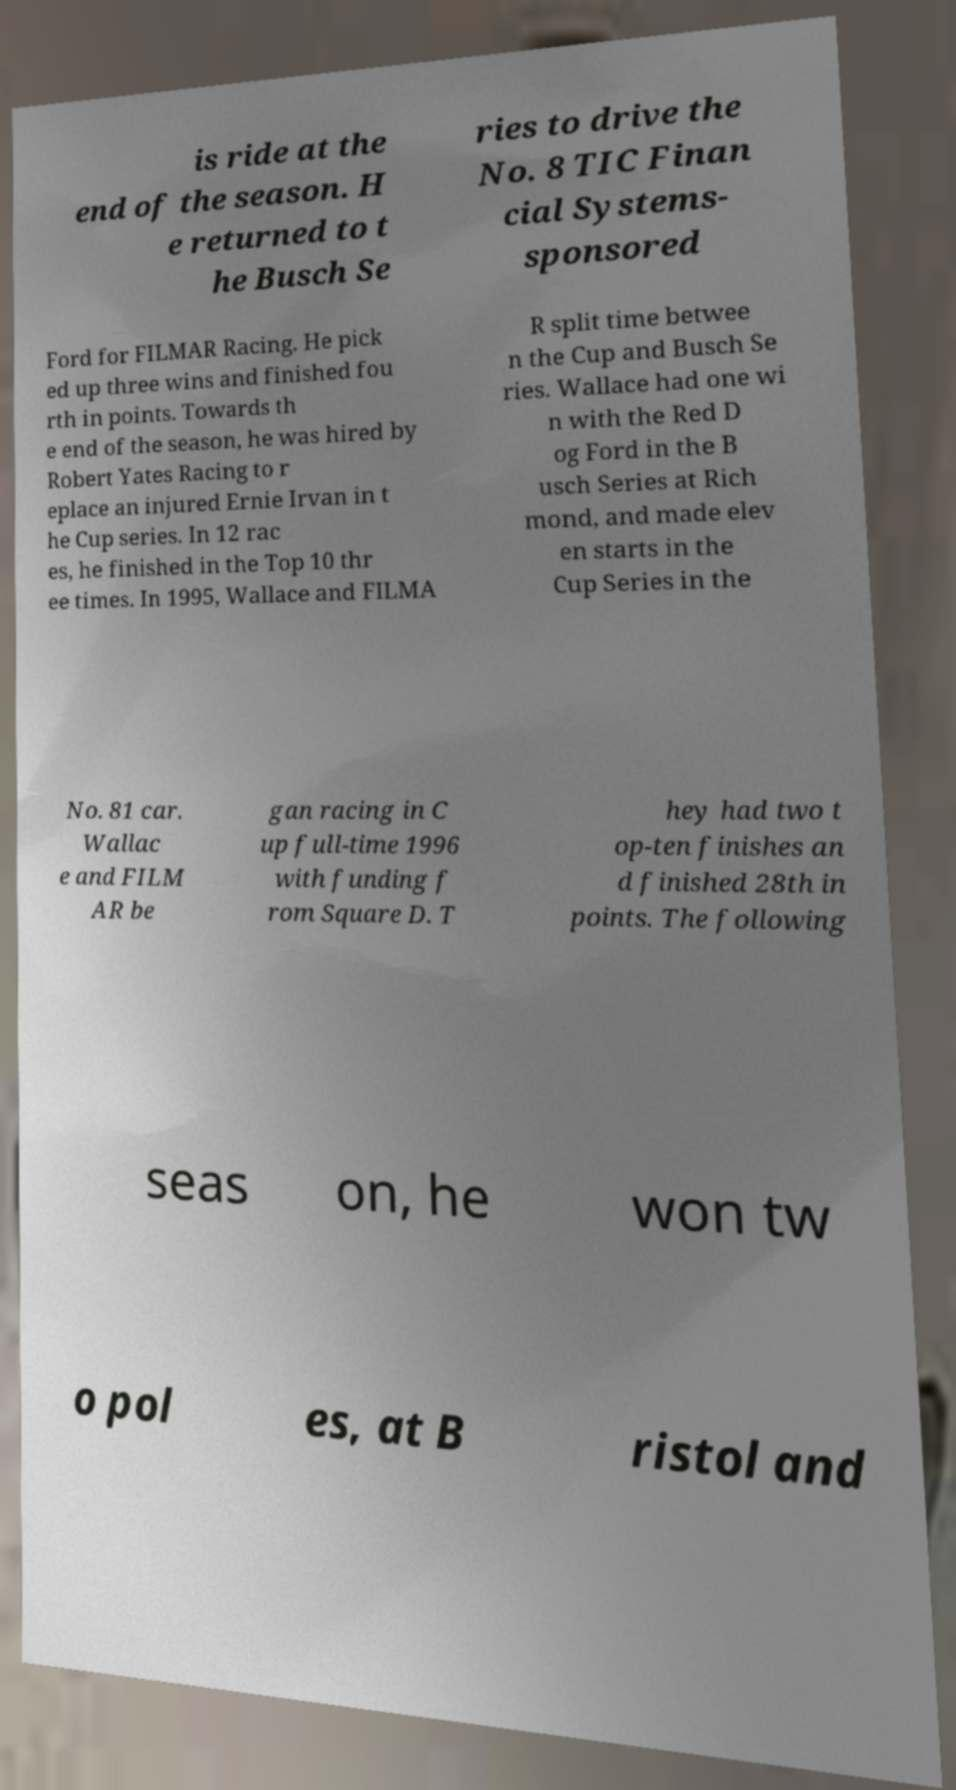For documentation purposes, I need the text within this image transcribed. Could you provide that? is ride at the end of the season. H e returned to t he Busch Se ries to drive the No. 8 TIC Finan cial Systems- sponsored Ford for FILMAR Racing. He pick ed up three wins and finished fou rth in points. Towards th e end of the season, he was hired by Robert Yates Racing to r eplace an injured Ernie Irvan in t he Cup series. In 12 rac es, he finished in the Top 10 thr ee times. In 1995, Wallace and FILMA R split time betwee n the Cup and Busch Se ries. Wallace had one wi n with the Red D og Ford in the B usch Series at Rich mond, and made elev en starts in the Cup Series in the No. 81 car. Wallac e and FILM AR be gan racing in C up full-time 1996 with funding f rom Square D. T hey had two t op-ten finishes an d finished 28th in points. The following seas on, he won tw o pol es, at B ristol and 